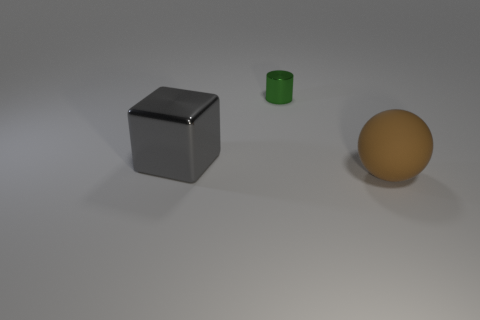Add 2 large green metallic balls. How many objects exist? 5 Subtract all spheres. How many objects are left? 2 Add 1 purple rubber things. How many purple rubber things exist? 1 Subtract 0 blue cubes. How many objects are left? 3 Subtract all tiny yellow metallic objects. Subtract all spheres. How many objects are left? 2 Add 1 shiny blocks. How many shiny blocks are left? 2 